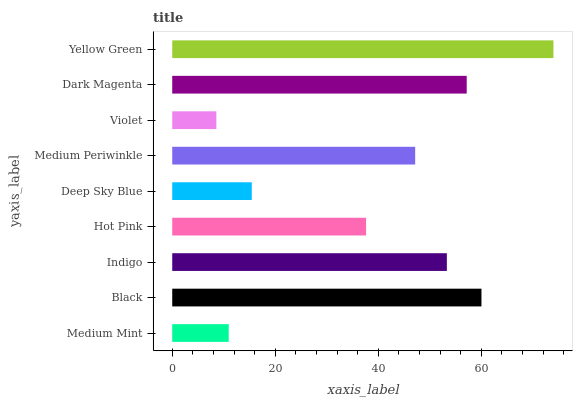Is Violet the minimum?
Answer yes or no. Yes. Is Yellow Green the maximum?
Answer yes or no. Yes. Is Black the minimum?
Answer yes or no. No. Is Black the maximum?
Answer yes or no. No. Is Black greater than Medium Mint?
Answer yes or no. Yes. Is Medium Mint less than Black?
Answer yes or no. Yes. Is Medium Mint greater than Black?
Answer yes or no. No. Is Black less than Medium Mint?
Answer yes or no. No. Is Medium Periwinkle the high median?
Answer yes or no. Yes. Is Medium Periwinkle the low median?
Answer yes or no. Yes. Is Black the high median?
Answer yes or no. No. Is Deep Sky Blue the low median?
Answer yes or no. No. 